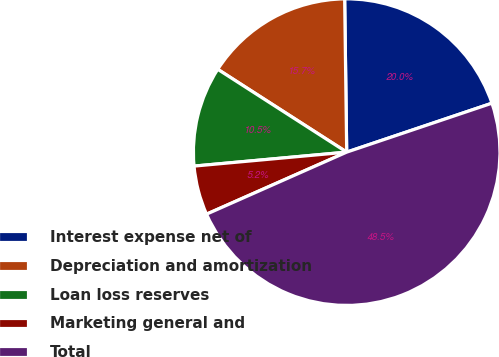Convert chart. <chart><loc_0><loc_0><loc_500><loc_500><pie_chart><fcel>Interest expense net of<fcel>Depreciation and amortization<fcel>Loan loss reserves<fcel>Marketing general and<fcel>Total<nl><fcel>20.04%<fcel>15.7%<fcel>10.54%<fcel>5.18%<fcel>48.54%<nl></chart> 